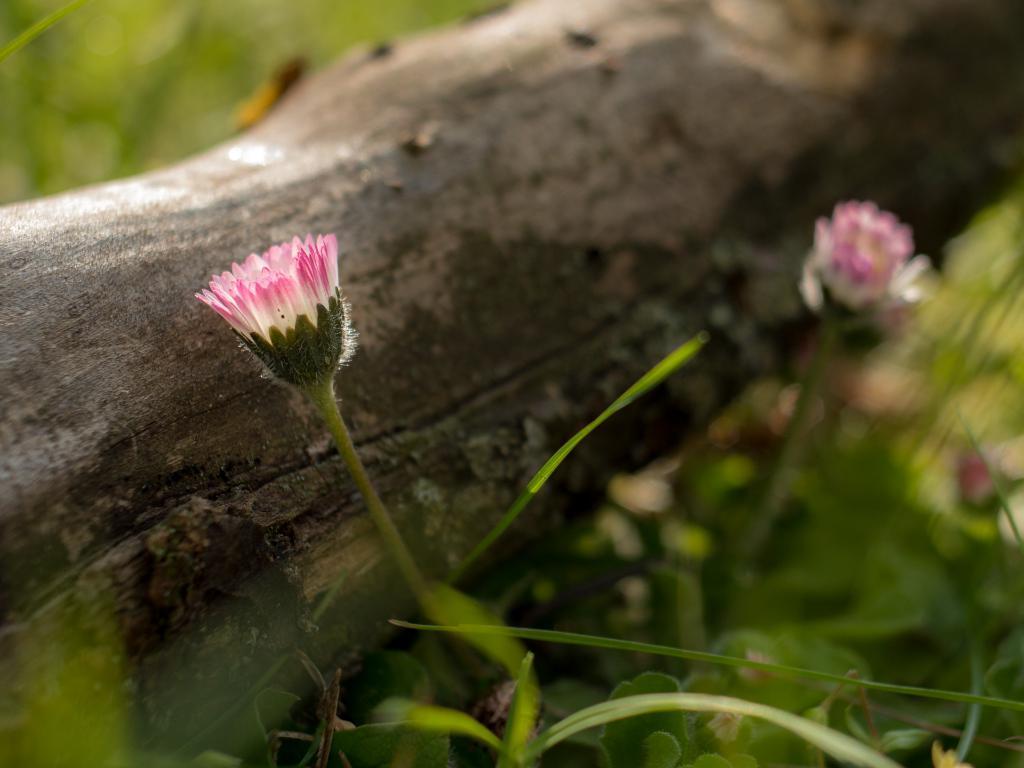In one or two sentences, can you explain what this image depicts? In this picture I can see a tree bark and few plants with flowers and flowers are white and purple in color. 